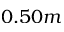Convert formula to latex. <formula><loc_0><loc_0><loc_500><loc_500>0 . 5 0 m</formula> 